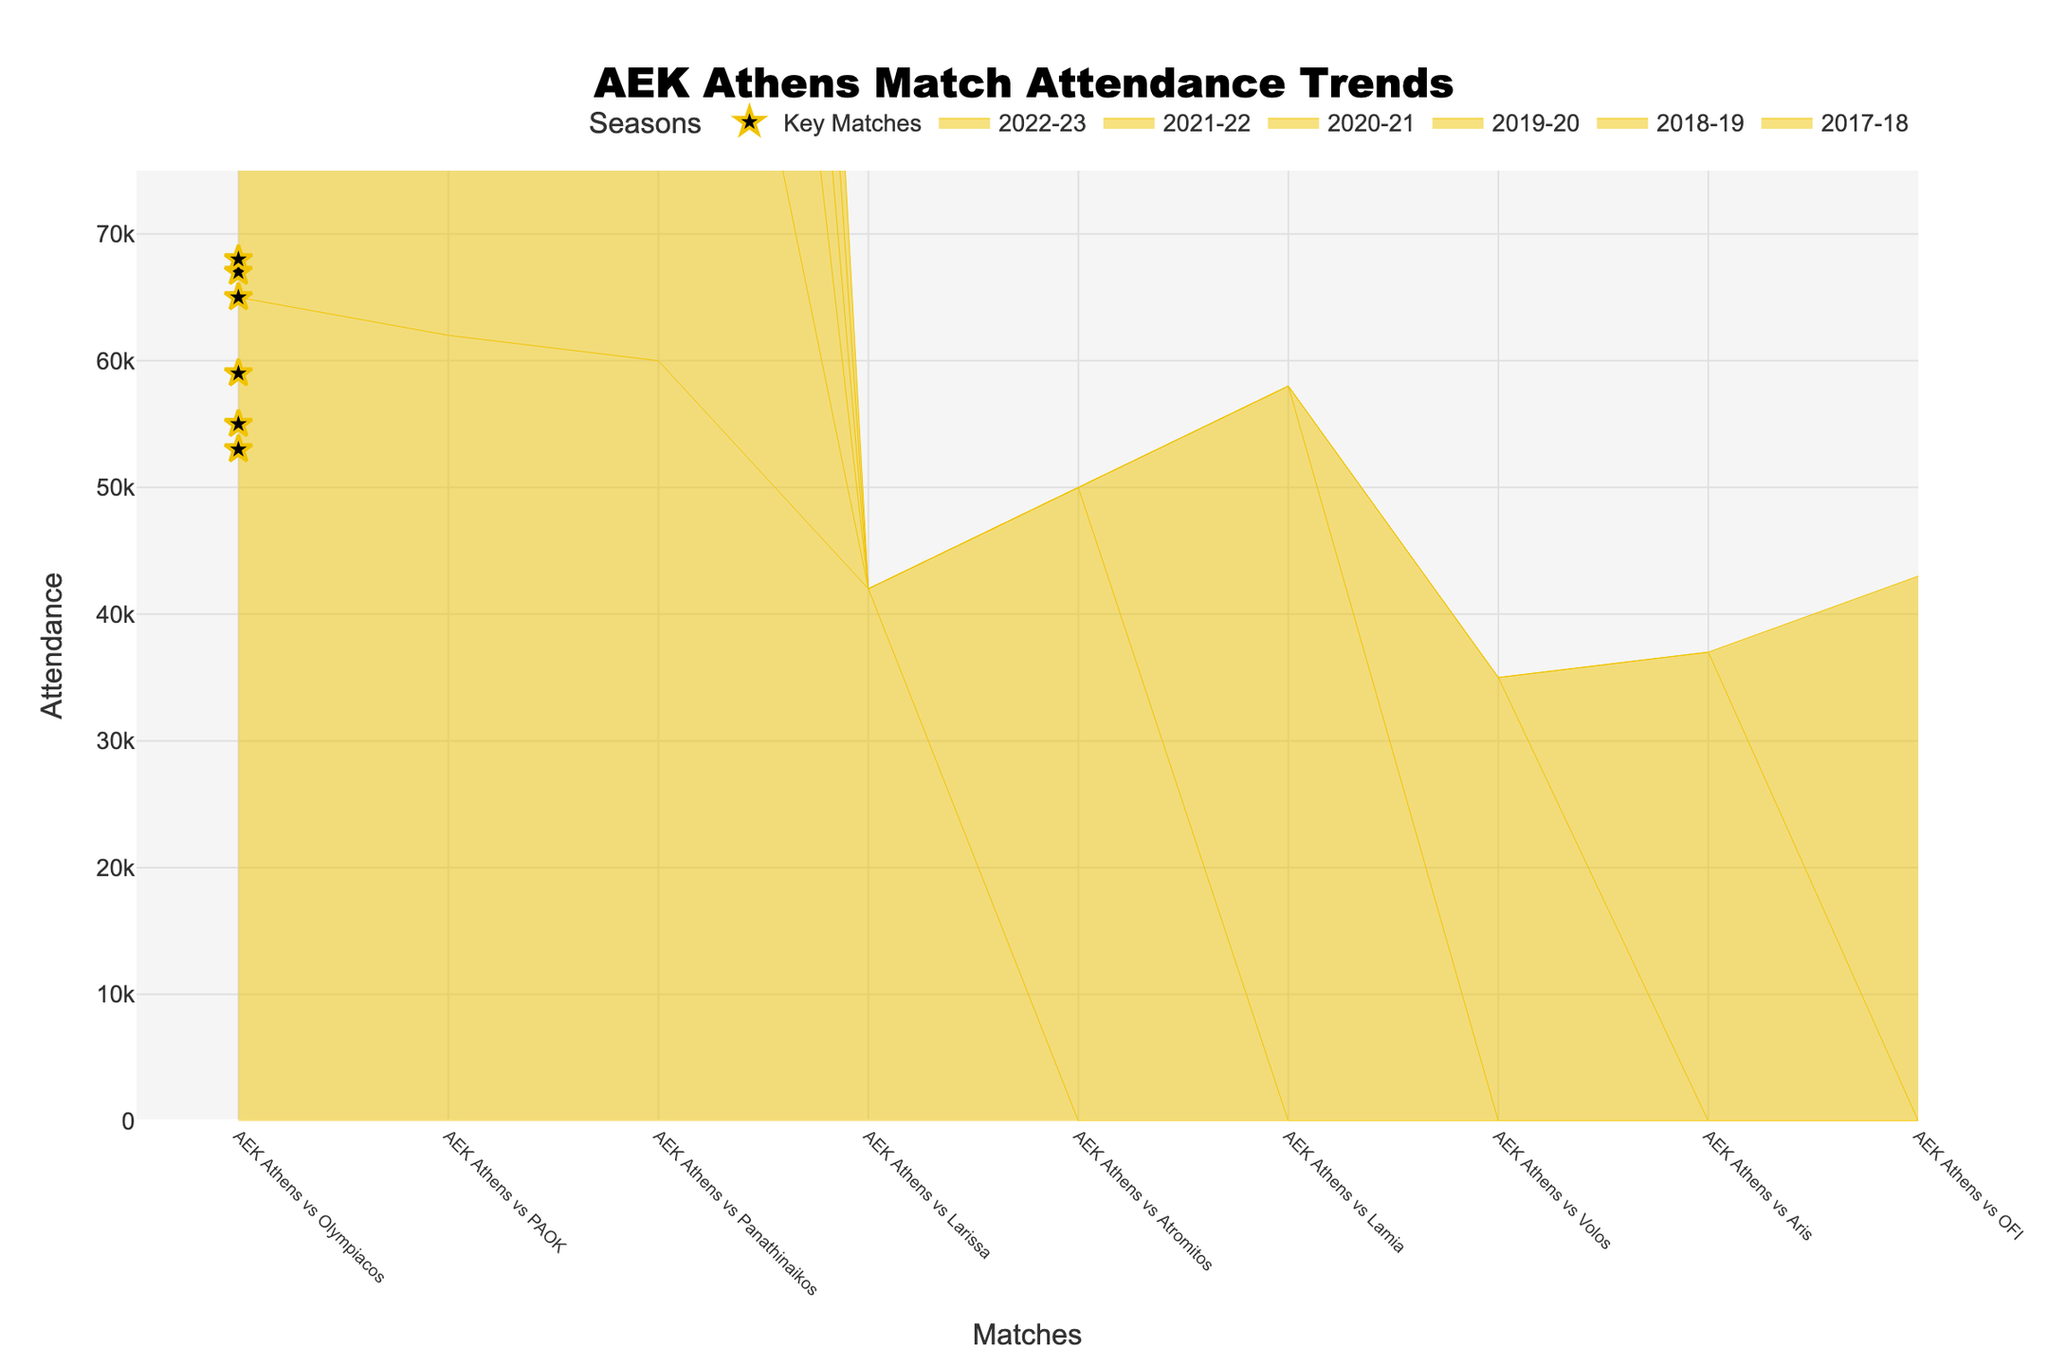What is the highest attendance recorded in the 2017-18 season? The highest attendance can be found by looking for the tallest step in the 2017-18 season area. For the 2017-18 season, the match with Olympiacos had 65,000 attendees, which is the highest.
Answer: 65,000 Which key match in the dataset had the lowest attendance? To identify the key match with the lowest attendance, look for the star markers and find the smallest value. The key match with the lowest attendance was against Olympiacos in the 2020-21 season with 53,000 attendees.
Answer: 53,000 How does the attendance for key matches in the 2022-23 season compare to that in the 2018-19 season? Compare the star markers for each season. In the 2022-23 season, the key match (Olympiacos) had an attendance of 59,000. In the 2018-19 season, the same opponent had an attendance of 67,000. Thus, the 2022-23 attendance is lower.
Answer: Lower What is the average attendance of all AEK Athens vs Olympiacos matches across the seasons? Count the matches against Olympiacos and calculate their average. The attendances are 65,000, 67,000, 68,000, 53,000, 55,000, and 59,000. Hence, average = (65,000 + 67,000 + 68,000 + 53,000 + 55,000 + 59,000) / 6 = 61,166.67.
Answer: 61,166.67 Which season had the widest range in match attendances? The range is calculated by subtracting the smallest attendance from the largest in each season. Assess the differences: 
2017-18: 65,000 - 42,000 = 23,000 
2018-19: 67,000 - 50,000 = 17,000 
2019-20: 68,000 - 58,000 = 10,000 
2020-21: 53,000 - 35,000 = 18,000 
2021-22: 55,000 - 37,000 = 18,000 
2022-23: 59,000 - 43,000 = 16,000 
The 2017-18 season had the widest range of 23,000.
Answer: 2017-18 How many key matches are highlighted in the dataset? Count the number of star markers each representing a key match. There is one highlighted key match per season for six seasons, giving a total of six key matches.
Answer: 6 What is the total attendance for all key matches combined? Sum up the attendance of all key matches indicated by star markers. The attendances are 65,000, 67,000, 68,000, 53,000, 55,000, and 59,000. Thus, the total is 65,000 + 67,000 + 68,000 + 53,000 + 55,000 + 59,000 = 367,000.
Answer: 367,000 Which match had the lowest attendance in the 2021-22 season? Examine the steps in the 2021-22 season area. The match against Aris had the lowest attendance of 37,000.
Answer: 37,000 Does attendance generally increase or decrease towards the end of the seasons? Look for trends in the accumulation of attendances across the steps in each season. Generally, attendance tends to start higher and taper off towards the end of the seasons.
Answer: Decrease 